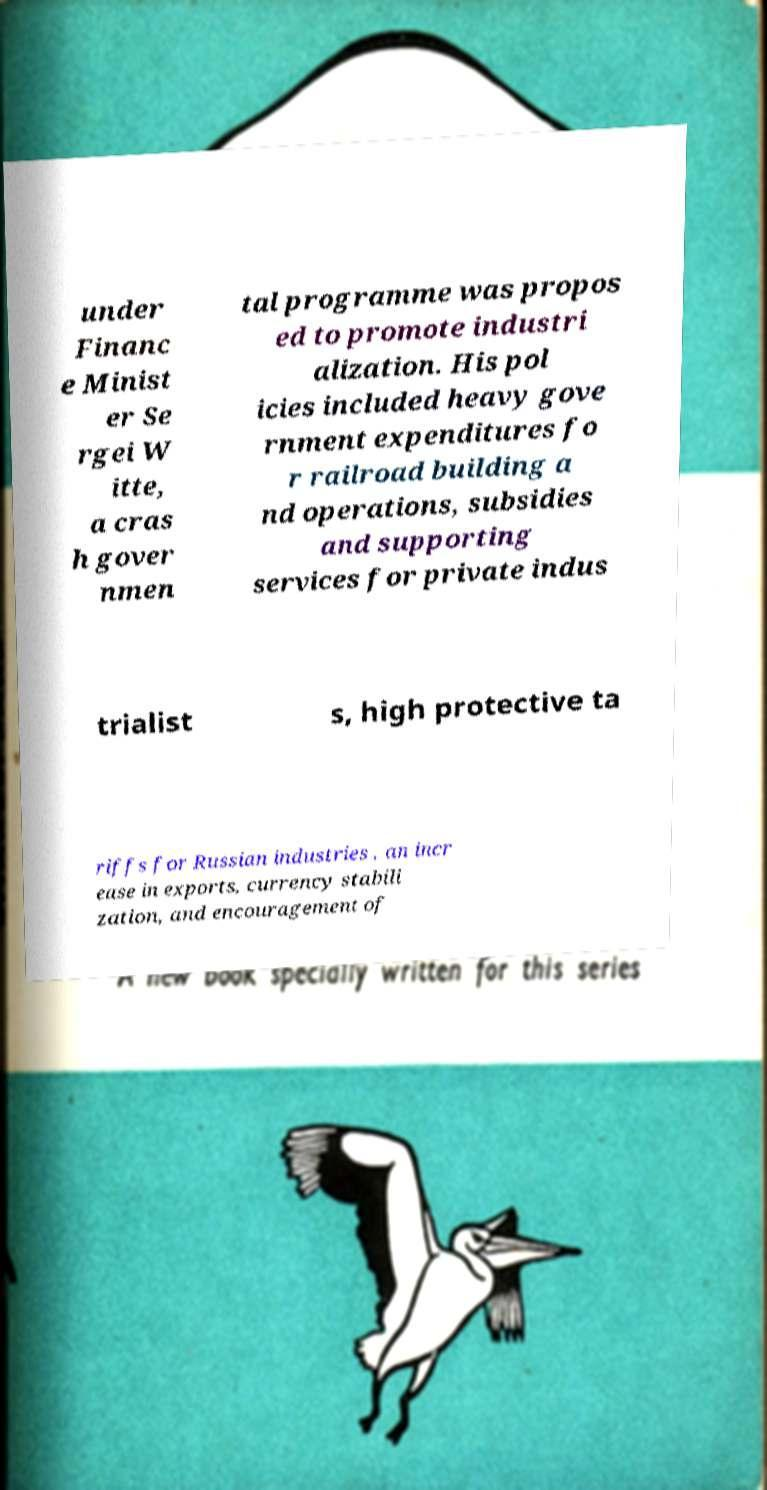Please identify and transcribe the text found in this image. under Financ e Minist er Se rgei W itte, a cras h gover nmen tal programme was propos ed to promote industri alization. His pol icies included heavy gove rnment expenditures fo r railroad building a nd operations, subsidies and supporting services for private indus trialist s, high protective ta riffs for Russian industries , an incr ease in exports, currency stabili zation, and encouragement of 